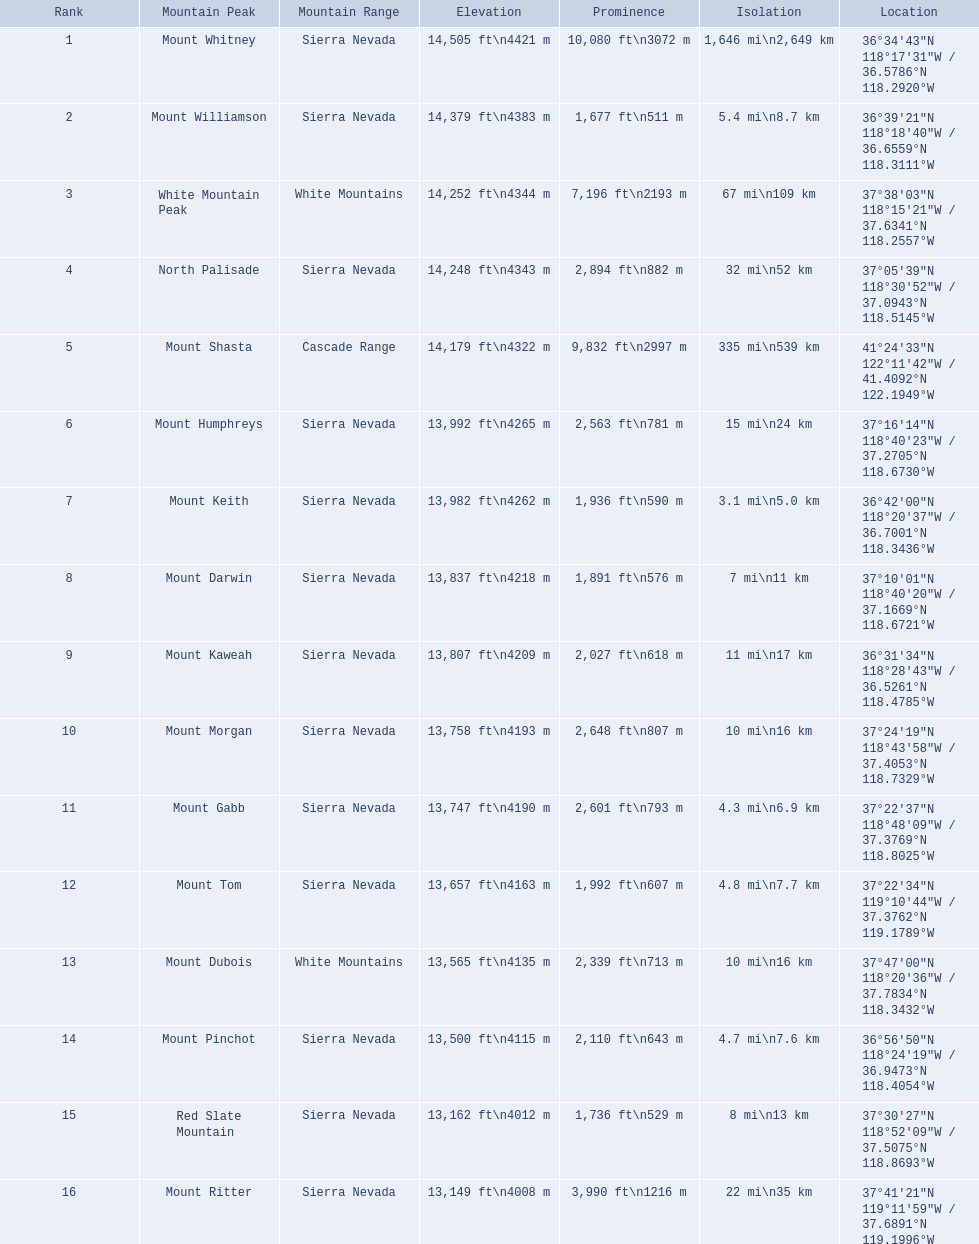What are the prominence heights exceeding 10,000 feet? 10,080 ft\n3072 m. Which mountain summit possesses a prominence of 10,080 feet? Mount Whitney. 